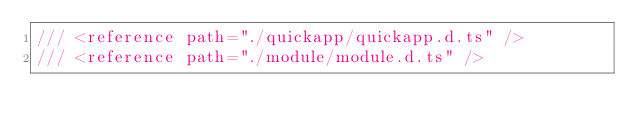<code> <loc_0><loc_0><loc_500><loc_500><_TypeScript_>/// <reference path="./quickapp/quickapp.d.ts" />
/// <reference path="./module/module.d.ts" /></code> 